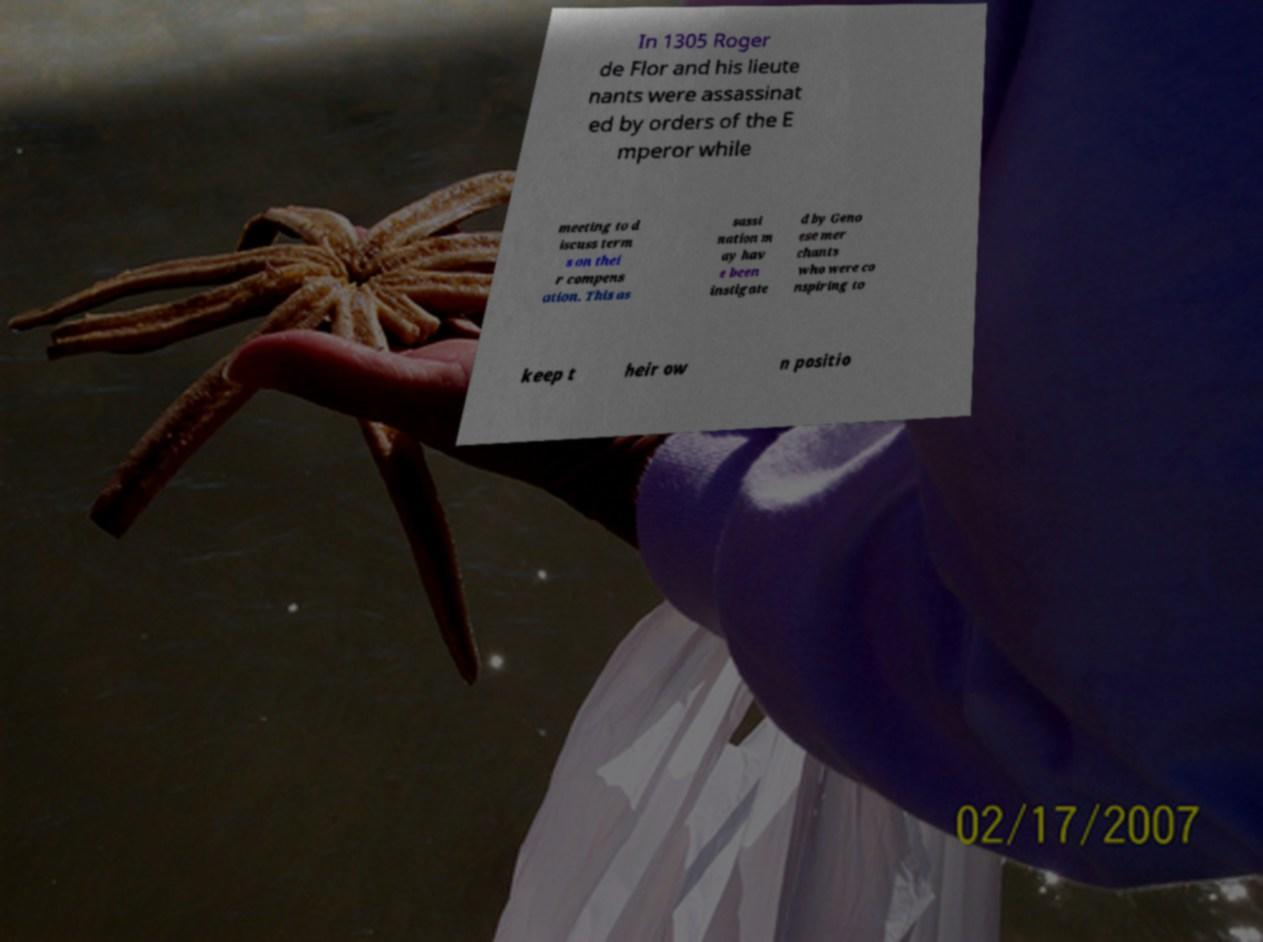There's text embedded in this image that I need extracted. Can you transcribe it verbatim? In 1305 Roger de Flor and his lieute nants were assassinat ed by orders of the E mperor while meeting to d iscuss term s on thei r compens ation. This as sassi nation m ay hav e been instigate d by Geno ese mer chants who were co nspiring to keep t heir ow n positio 